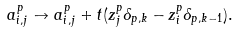<formula> <loc_0><loc_0><loc_500><loc_500>a _ { i , j } ^ { p } \to a _ { i , j } ^ { p } + t ( z _ { j } ^ { p } \delta _ { p , k } - z _ { i } ^ { p } \delta _ { p , k - 1 } ) .</formula> 